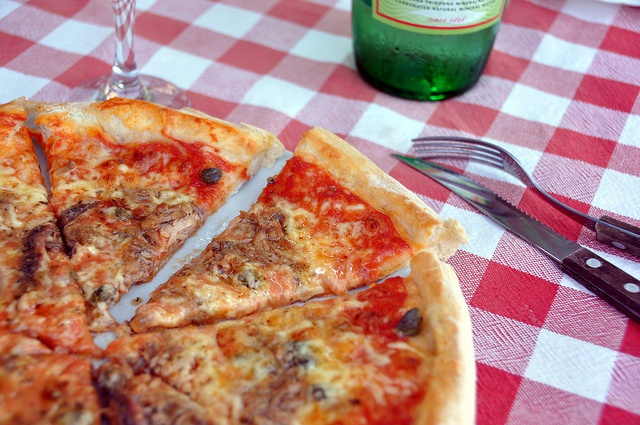Describe the objects in this image and their specific colors. I can see dining table in lightblue, pink, and lightpink tones, pizza in lightblue, tan, and brown tones, pizza in lightblue, tan, brown, and red tones, pizza in lightblue, tan, brown, red, and salmon tones, and bottle in lightblue, black, darkgreen, and green tones in this image. 